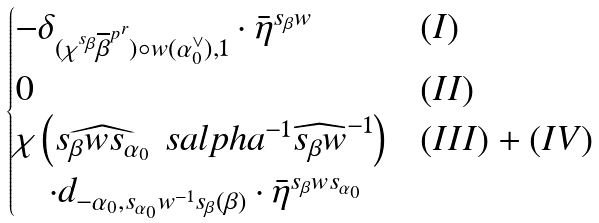<formula> <loc_0><loc_0><loc_500><loc_500>\begin{cases} - \delta _ { ( \chi ^ { s _ { \beta } } \overline { \beta } ^ { p ^ { r } } ) \circ w ( \alpha _ { 0 } ^ { \vee } ) , 1 } \cdot \bar { \eta } ^ { s _ { \beta } w } & ( I ) \\ 0 & ( I I ) \\ \chi \left ( \widehat { s _ { \beta } w s _ { \alpha _ { 0 } } } \ s a l p h a ^ { - 1 } \widehat { s _ { \beta } w } ^ { - 1 } \right ) & ( I I I ) + ( I V ) \\ \quad \cdot d _ { - \alpha _ { 0 } , s _ { \alpha _ { 0 } } w ^ { - 1 } s _ { \beta } ( \beta ) } \cdot \bar { \eta } ^ { s _ { \beta } w s _ { \alpha _ { 0 } } } & \end{cases}</formula> 